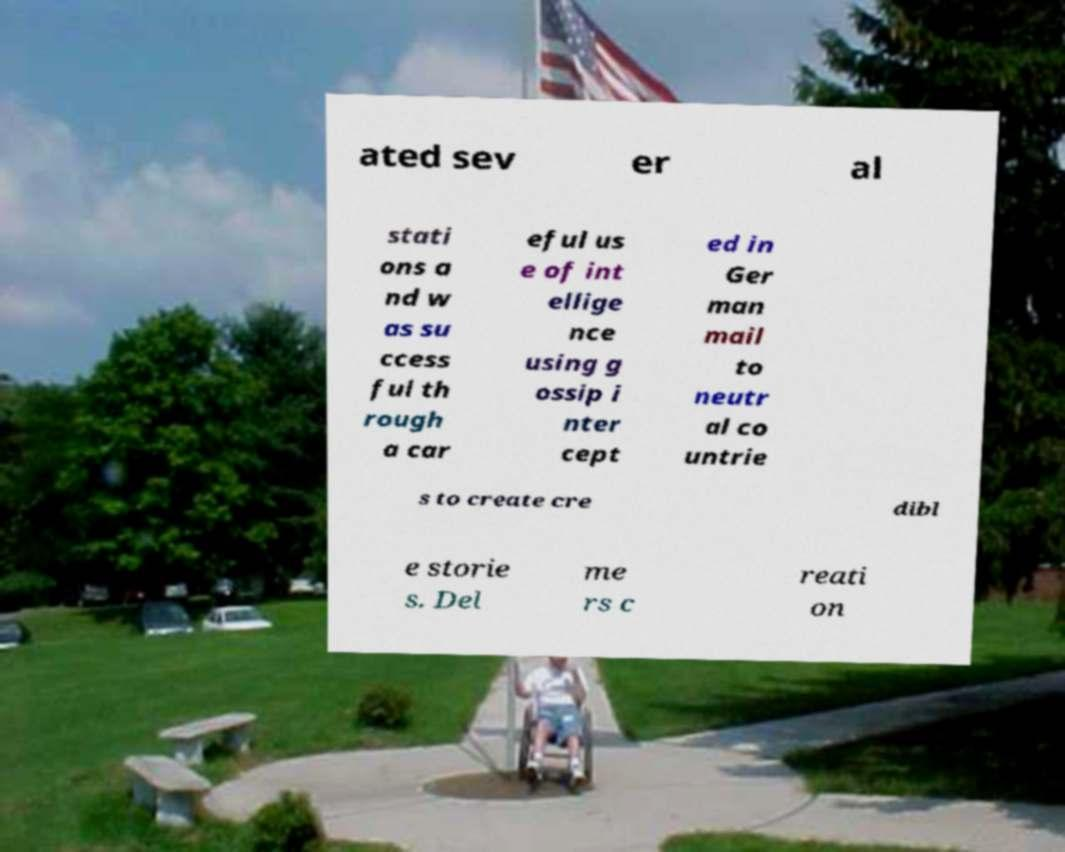Please read and relay the text visible in this image. What does it say? ated sev er al stati ons a nd w as su ccess ful th rough a car eful us e of int ellige nce using g ossip i nter cept ed in Ger man mail to neutr al co untrie s to create cre dibl e storie s. Del me rs c reati on 